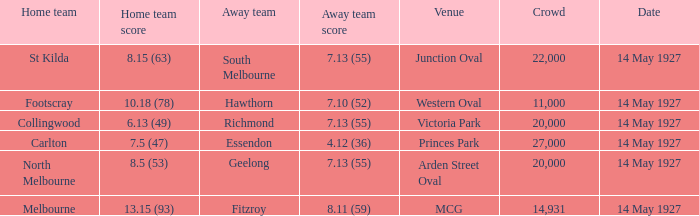Which venue hosted a home team with a score of 13.15 (93)? MCG. 